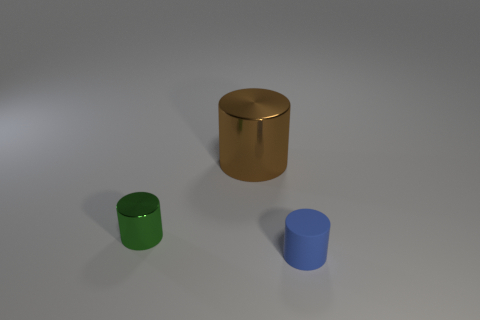Add 2 tiny things. How many objects exist? 5 Add 3 large red metallic objects. How many large red metallic objects exist? 3 Subtract 0 red blocks. How many objects are left? 3 Subtract all brown cylinders. Subtract all small purple matte spheres. How many objects are left? 2 Add 3 big brown metal things. How many big brown metal things are left? 4 